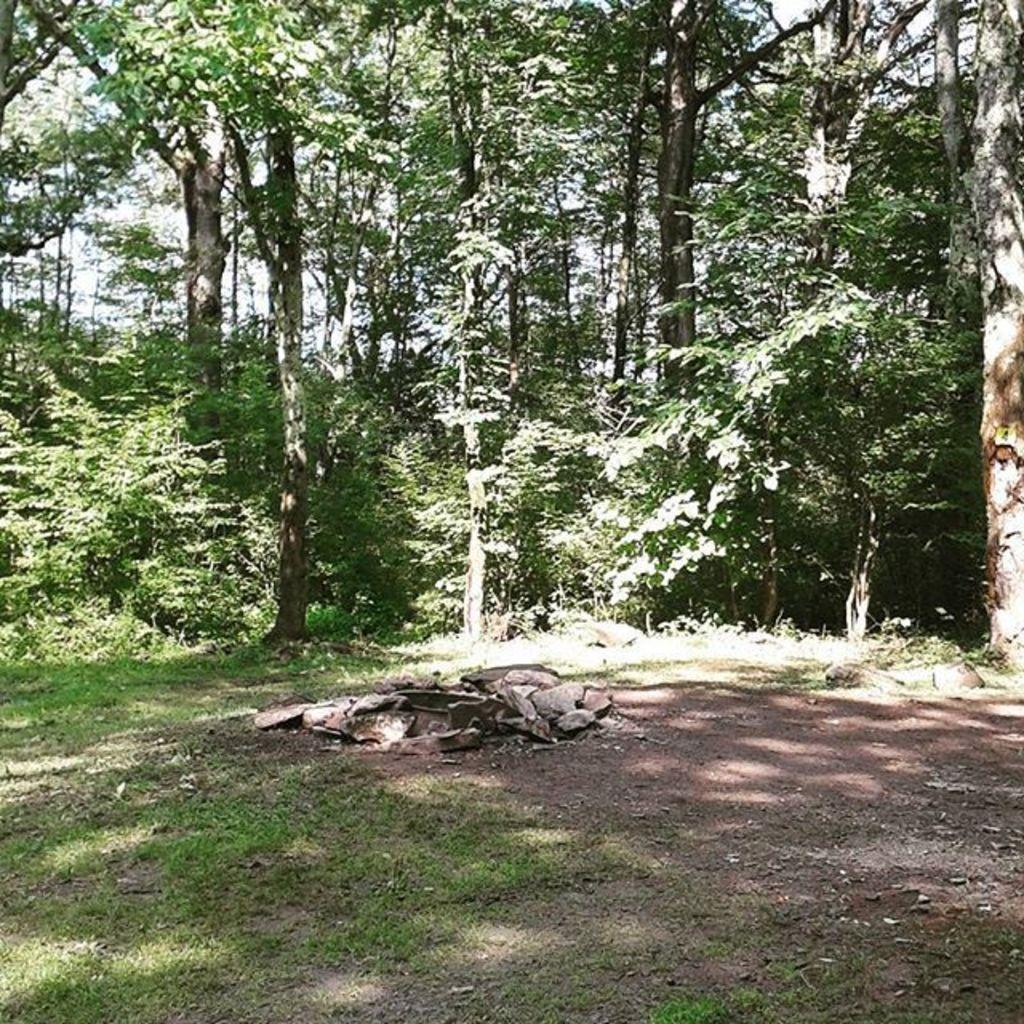What type of vegetation is present at the bottom of the image? There is grass on the ground at the bottom of the image. What else can be seen on the ground at the bottom of the image? There are objects on the ground at the bottom of the image. What can be seen in the distance in the image? There are trees in the background of the image. Can you see the tail of the chicken in the image? There is no chicken present in the image, so there is no tail to be seen. 